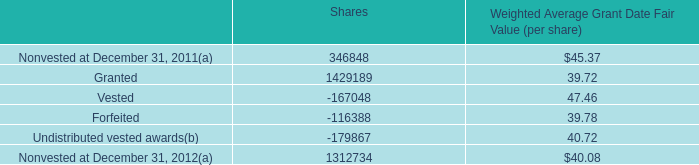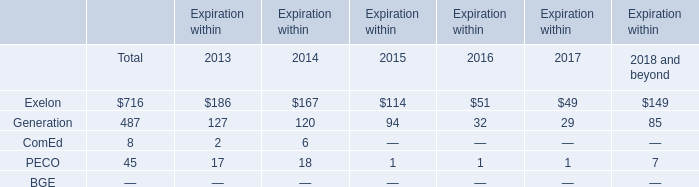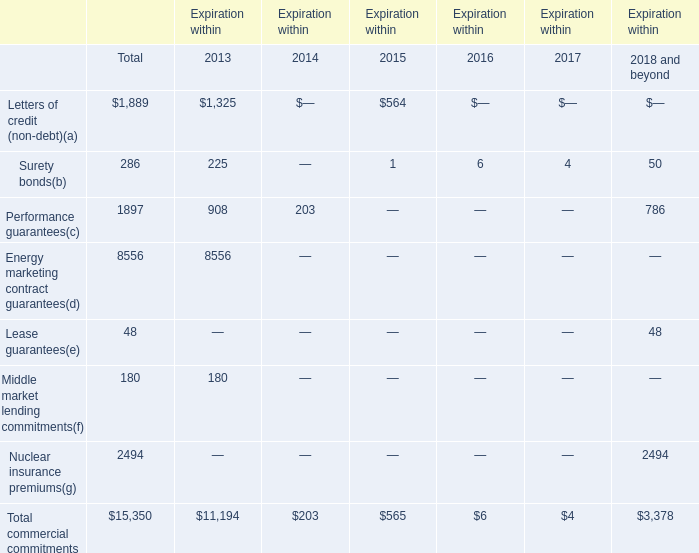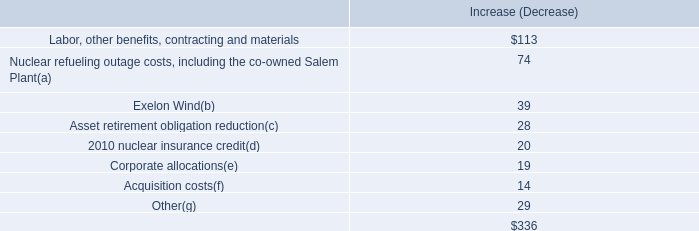What is the total value of Exelon, Generation, ComEd and PECO in in 2013? 
Computations: (((186 + 127) + 2) + 17)
Answer: 332.0. 